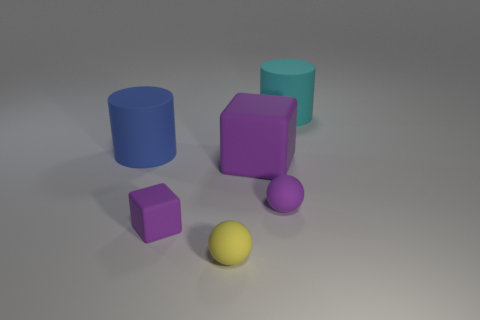What is the texture and lighting like on the objects, and what mood does it evoke? The objects appear to have a matte texture and are lit from above, casting soft shadows on the ground. The lighting creates a calm and contemplative mood, highlighting the simplicity and the clean design of the objects. 